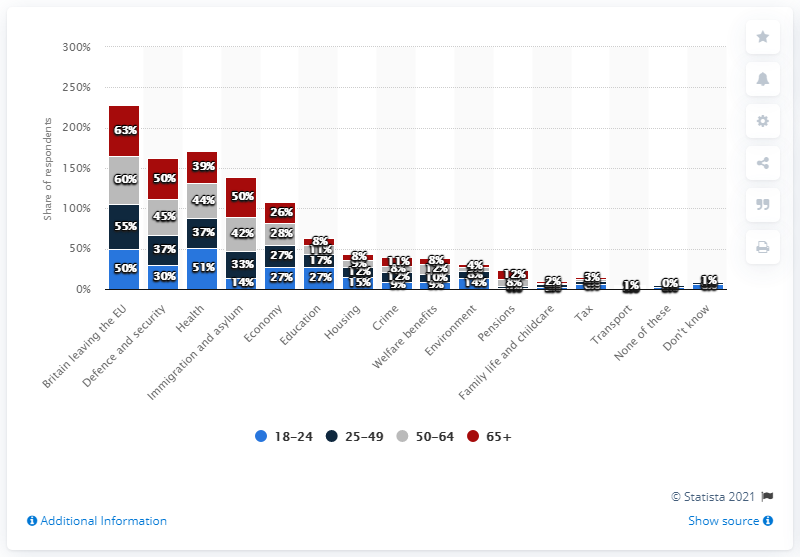Specify some key components in this picture. According to the survey, 50% of respondents aged 65 or older expressed concern about national defense and security issues. 